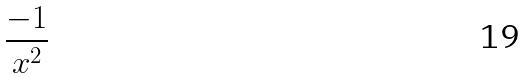Convert formula to latex. <formula><loc_0><loc_0><loc_500><loc_500>\frac { - 1 } { x ^ { 2 } }</formula> 